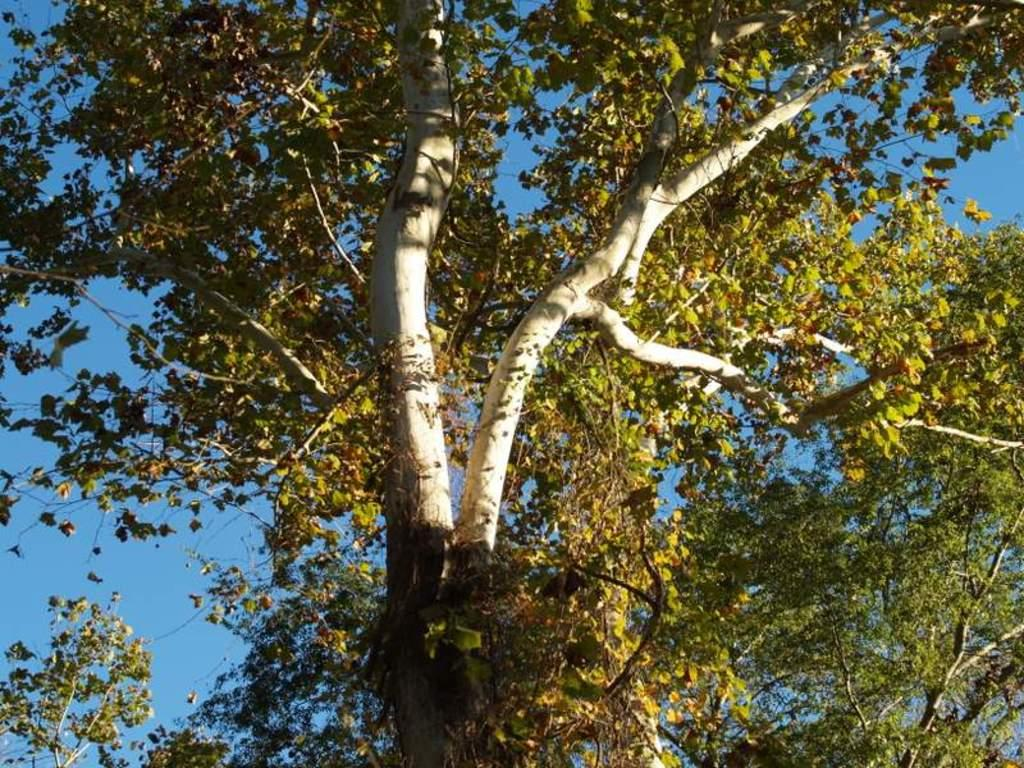What type of vegetation can be seen in the image? There are trees in the image. What part of the natural environment is visible in the background of the image? The sky is visible in the background of the image. What type of horn can be seen on the trees in the image? There are no horns present on the trees in the image. What kind of toys can be seen scattered around the base of the trees in the image? There are no toys present in the image; it only features trees and the sky. 